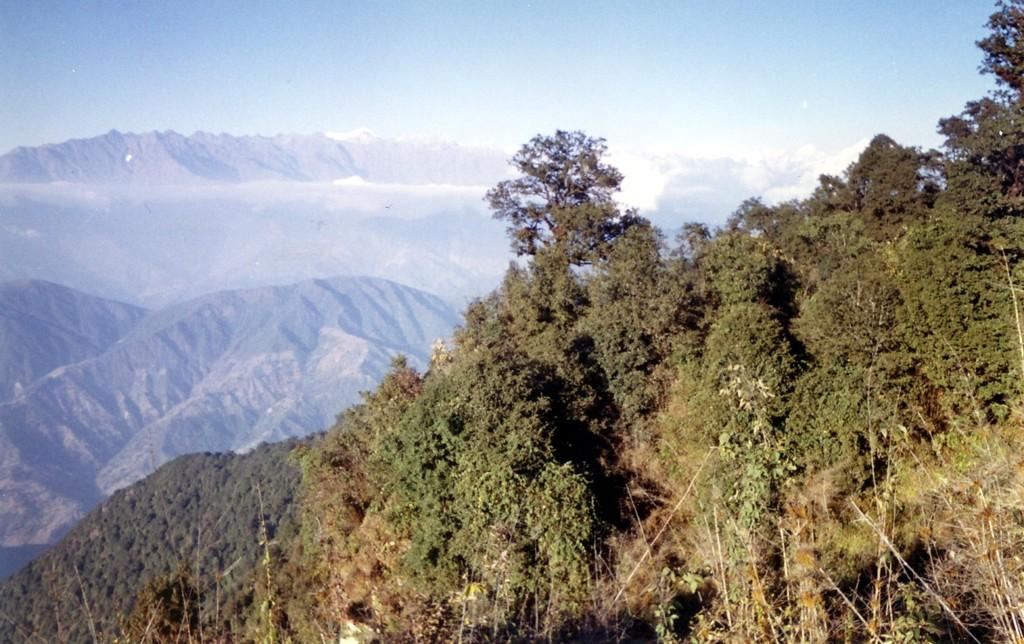What type of vegetation can be seen on the hills in the image? There are trees on the hills in the image. What type of geographical feature is present in the image? There are mountains in the image. What is visible in the sky in the image? The sky is visible in the image. What can be observed in the sky along with the sky in the image? Clouds are present in the sky in the image. Can you tell me how many creatures are interacting with the mountains in the image? There are no creatures present in the image; it features trees on hills, mountains, and clouds in the sky. What type of scale is used to measure the height of the mountains in the image? There is no scale present in the image to measure the height of the mountains. 